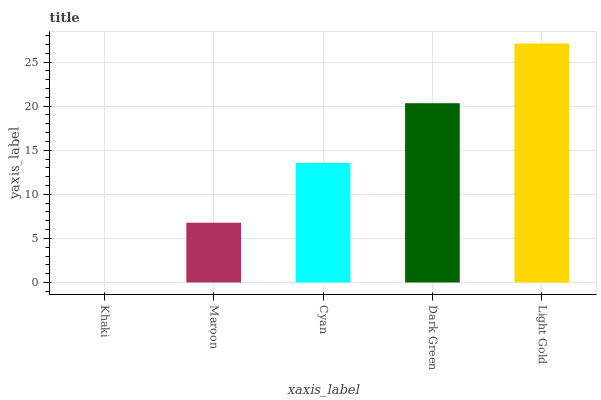Is Khaki the minimum?
Answer yes or no. Yes. Is Light Gold the maximum?
Answer yes or no. Yes. Is Maroon the minimum?
Answer yes or no. No. Is Maroon the maximum?
Answer yes or no. No. Is Maroon greater than Khaki?
Answer yes or no. Yes. Is Khaki less than Maroon?
Answer yes or no. Yes. Is Khaki greater than Maroon?
Answer yes or no. No. Is Maroon less than Khaki?
Answer yes or no. No. Is Cyan the high median?
Answer yes or no. Yes. Is Cyan the low median?
Answer yes or no. Yes. Is Maroon the high median?
Answer yes or no. No. Is Light Gold the low median?
Answer yes or no. No. 